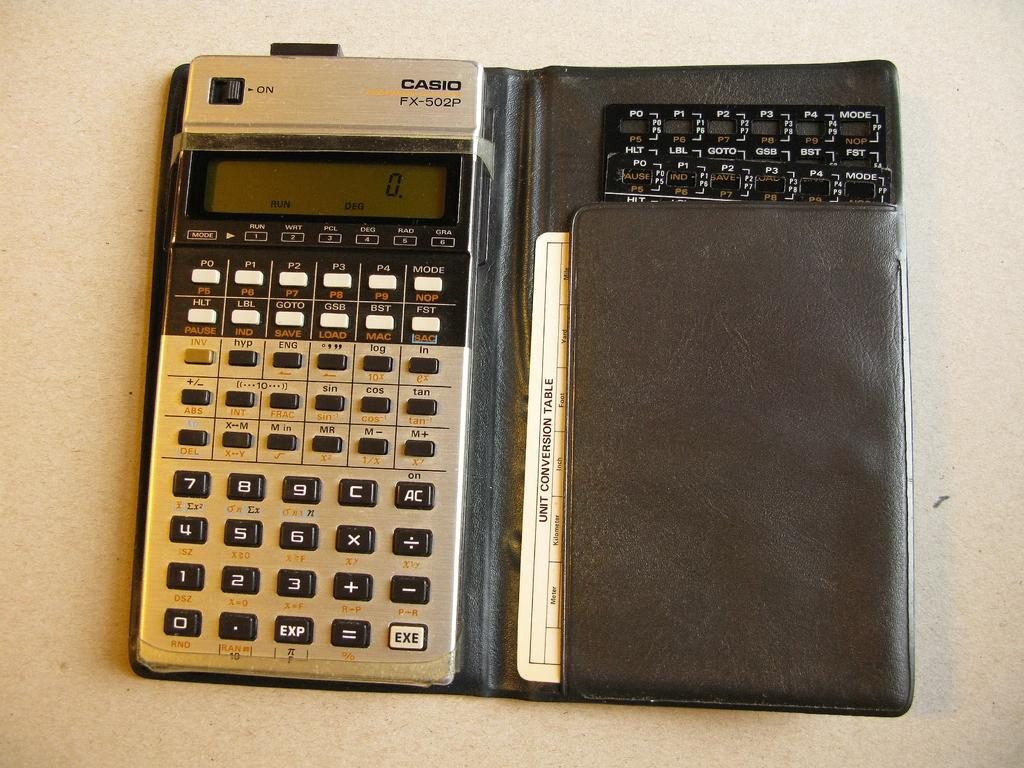<image>
Share a concise interpretation of the image provided. The Casio FX-502P calculator is displaying 0 on the screen. 